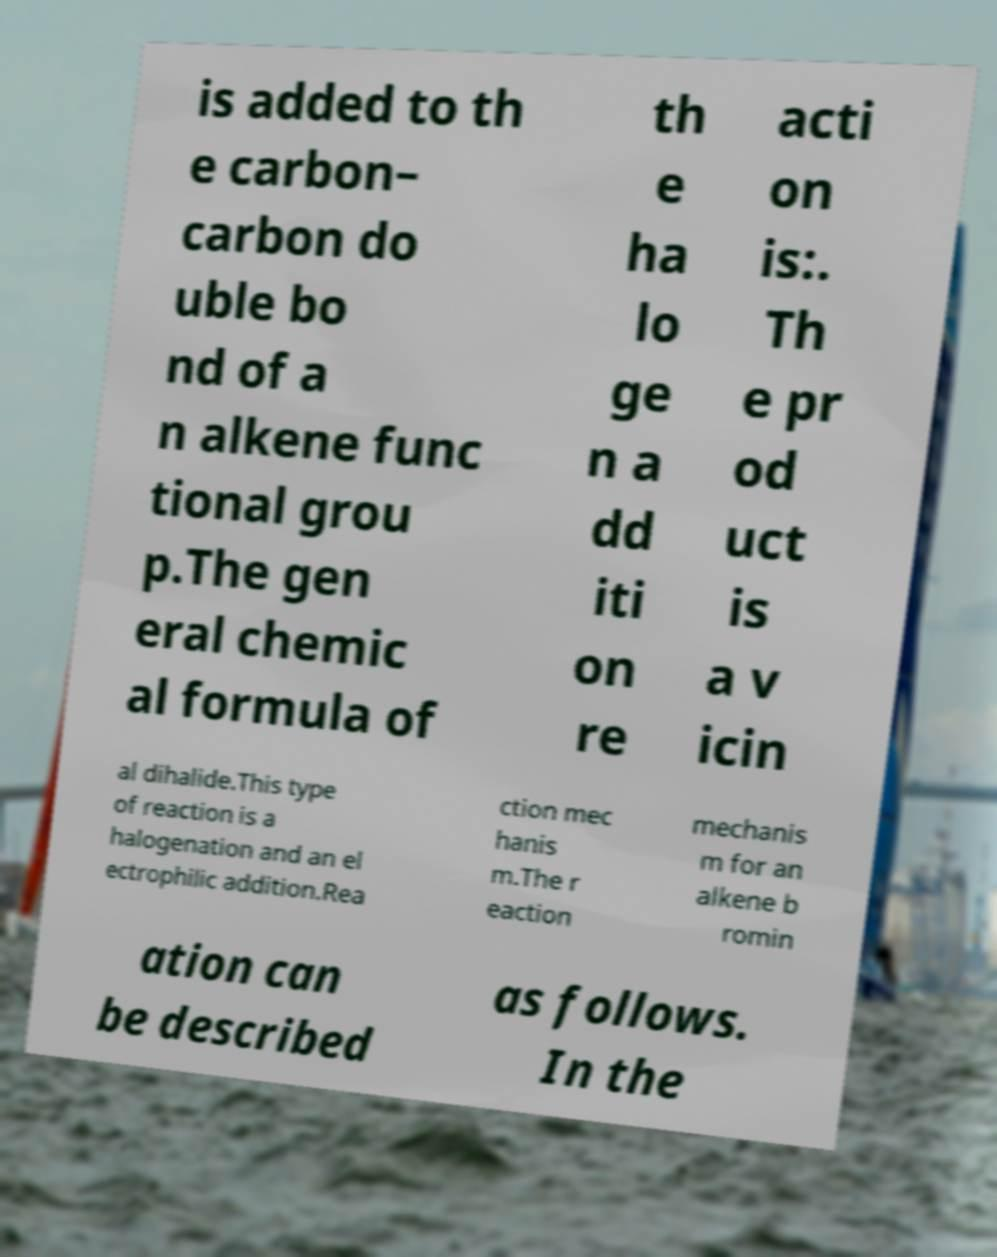Please identify and transcribe the text found in this image. is added to th e carbon– carbon do uble bo nd of a n alkene func tional grou p.The gen eral chemic al formula of th e ha lo ge n a dd iti on re acti on is:. Th e pr od uct is a v icin al dihalide.This type of reaction is a halogenation and an el ectrophilic addition.Rea ction mec hanis m.The r eaction mechanis m for an alkene b romin ation can be described as follows. In the 